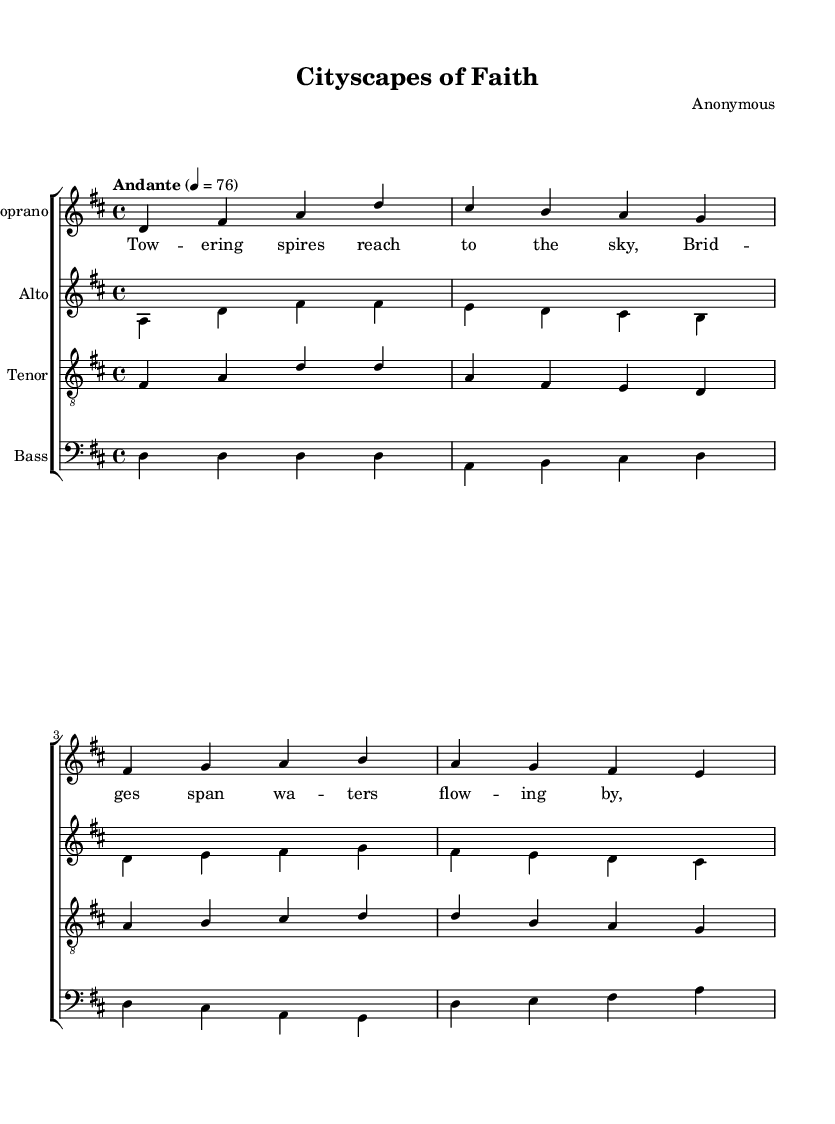What is the key signature of this music? The key signature is two sharps, which indicates that the piece is in the key of D major. The sharps are F# and C#.
Answer: D major What is the time signature of this piece? The time signature, found at the beginning of the music, shows 4/4, meaning there are four beats in each measure and a quarter note receives one beat.
Answer: 4/4 What is the tempo marking for this piece? The tempo marking provided indicates "Andante," meaning the piece is played at a moderate walking pace, specifically defined here as 76 beats per minute.
Answer: Andante Which voices are included in the choral arrangement? The arrangement consists of four voices: Soprano, Alto, Tenor, and Bass. These are labeled at the beginning of each staff in the score.
Answer: Soprano, Alto, Tenor, Bass How many measures are in the soprano part? To determine the number of measures, we count the distinct groups of notes separated by vertical lines in the soprano part, which totals four measures.
Answer: 4 What is the lyrical theme of the first verse? The lyrics of the first verse depict imagery of "towering spires" and "bridges," suggesting a connection to religious and architectural beauty in the city.
Answer: Towering spires; bridges Which voice has the highest pitch in this arrangement? By comparing the notated pitches across all parts, the Soprano voice reaches the highest notes, making it the highest in pitch among the four voices.
Answer: Soprano 